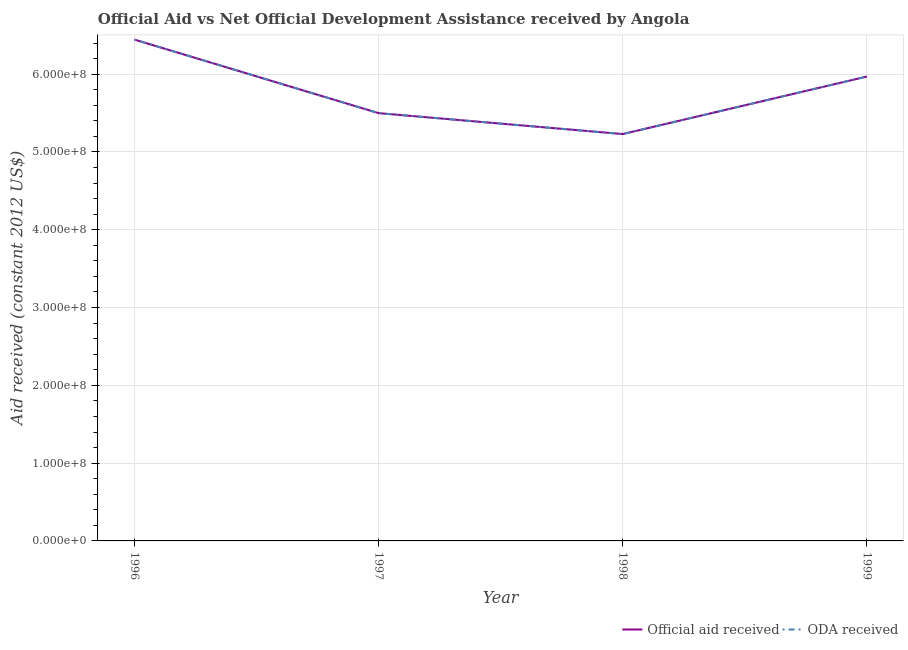What is the official aid received in 1996?
Provide a succinct answer. 6.44e+08. Across all years, what is the maximum oda received?
Keep it short and to the point. 6.44e+08. Across all years, what is the minimum oda received?
Offer a terse response. 5.23e+08. In which year was the oda received minimum?
Your response must be concise. 1998. What is the total official aid received in the graph?
Ensure brevity in your answer.  2.31e+09. What is the difference between the oda received in 1997 and that in 1998?
Give a very brief answer. 2.69e+07. What is the difference between the official aid received in 1997 and the oda received in 1996?
Keep it short and to the point. -9.46e+07. What is the average oda received per year?
Your answer should be compact. 5.79e+08. In how many years, is the official aid received greater than 340000000 US$?
Ensure brevity in your answer.  4. What is the ratio of the oda received in 1996 to that in 1999?
Your answer should be very brief. 1.08. What is the difference between the highest and the second highest oda received?
Provide a short and direct response. 4.75e+07. What is the difference between the highest and the lowest official aid received?
Offer a terse response. 1.21e+08. Does the oda received monotonically increase over the years?
Provide a succinct answer. No. Is the official aid received strictly greater than the oda received over the years?
Your answer should be very brief. No. Is the oda received strictly less than the official aid received over the years?
Offer a very short reply. No. How many lines are there?
Offer a terse response. 2. What is the difference between two consecutive major ticks on the Y-axis?
Keep it short and to the point. 1.00e+08. Does the graph contain any zero values?
Offer a terse response. No. Does the graph contain grids?
Offer a terse response. Yes. Where does the legend appear in the graph?
Provide a short and direct response. Bottom right. How many legend labels are there?
Offer a terse response. 2. What is the title of the graph?
Your response must be concise. Official Aid vs Net Official Development Assistance received by Angola . Does "National Tourists" appear as one of the legend labels in the graph?
Provide a short and direct response. No. What is the label or title of the Y-axis?
Ensure brevity in your answer.  Aid received (constant 2012 US$). What is the Aid received (constant 2012 US$) of Official aid received in 1996?
Ensure brevity in your answer.  6.44e+08. What is the Aid received (constant 2012 US$) in ODA received in 1996?
Keep it short and to the point. 6.44e+08. What is the Aid received (constant 2012 US$) in Official aid received in 1997?
Keep it short and to the point. 5.50e+08. What is the Aid received (constant 2012 US$) of ODA received in 1997?
Offer a very short reply. 5.50e+08. What is the Aid received (constant 2012 US$) in Official aid received in 1998?
Your answer should be very brief. 5.23e+08. What is the Aid received (constant 2012 US$) in ODA received in 1998?
Offer a terse response. 5.23e+08. What is the Aid received (constant 2012 US$) in Official aid received in 1999?
Provide a succinct answer. 5.97e+08. What is the Aid received (constant 2012 US$) of ODA received in 1999?
Offer a very short reply. 5.97e+08. Across all years, what is the maximum Aid received (constant 2012 US$) of Official aid received?
Offer a terse response. 6.44e+08. Across all years, what is the maximum Aid received (constant 2012 US$) of ODA received?
Ensure brevity in your answer.  6.44e+08. Across all years, what is the minimum Aid received (constant 2012 US$) in Official aid received?
Keep it short and to the point. 5.23e+08. Across all years, what is the minimum Aid received (constant 2012 US$) in ODA received?
Make the answer very short. 5.23e+08. What is the total Aid received (constant 2012 US$) of Official aid received in the graph?
Provide a succinct answer. 2.31e+09. What is the total Aid received (constant 2012 US$) in ODA received in the graph?
Offer a very short reply. 2.31e+09. What is the difference between the Aid received (constant 2012 US$) in Official aid received in 1996 and that in 1997?
Offer a terse response. 9.46e+07. What is the difference between the Aid received (constant 2012 US$) of ODA received in 1996 and that in 1997?
Ensure brevity in your answer.  9.46e+07. What is the difference between the Aid received (constant 2012 US$) of Official aid received in 1996 and that in 1998?
Offer a very short reply. 1.21e+08. What is the difference between the Aid received (constant 2012 US$) in ODA received in 1996 and that in 1998?
Your response must be concise. 1.21e+08. What is the difference between the Aid received (constant 2012 US$) in Official aid received in 1996 and that in 1999?
Your answer should be very brief. 4.75e+07. What is the difference between the Aid received (constant 2012 US$) in ODA received in 1996 and that in 1999?
Keep it short and to the point. 4.75e+07. What is the difference between the Aid received (constant 2012 US$) in Official aid received in 1997 and that in 1998?
Provide a succinct answer. 2.69e+07. What is the difference between the Aid received (constant 2012 US$) in ODA received in 1997 and that in 1998?
Ensure brevity in your answer.  2.69e+07. What is the difference between the Aid received (constant 2012 US$) in Official aid received in 1997 and that in 1999?
Your response must be concise. -4.71e+07. What is the difference between the Aid received (constant 2012 US$) in ODA received in 1997 and that in 1999?
Your answer should be very brief. -4.71e+07. What is the difference between the Aid received (constant 2012 US$) in Official aid received in 1998 and that in 1999?
Give a very brief answer. -7.39e+07. What is the difference between the Aid received (constant 2012 US$) in ODA received in 1998 and that in 1999?
Give a very brief answer. -7.39e+07. What is the difference between the Aid received (constant 2012 US$) in Official aid received in 1996 and the Aid received (constant 2012 US$) in ODA received in 1997?
Keep it short and to the point. 9.46e+07. What is the difference between the Aid received (constant 2012 US$) in Official aid received in 1996 and the Aid received (constant 2012 US$) in ODA received in 1998?
Provide a short and direct response. 1.21e+08. What is the difference between the Aid received (constant 2012 US$) in Official aid received in 1996 and the Aid received (constant 2012 US$) in ODA received in 1999?
Make the answer very short. 4.75e+07. What is the difference between the Aid received (constant 2012 US$) of Official aid received in 1997 and the Aid received (constant 2012 US$) of ODA received in 1998?
Make the answer very short. 2.69e+07. What is the difference between the Aid received (constant 2012 US$) in Official aid received in 1997 and the Aid received (constant 2012 US$) in ODA received in 1999?
Offer a very short reply. -4.71e+07. What is the difference between the Aid received (constant 2012 US$) of Official aid received in 1998 and the Aid received (constant 2012 US$) of ODA received in 1999?
Offer a terse response. -7.39e+07. What is the average Aid received (constant 2012 US$) of Official aid received per year?
Keep it short and to the point. 5.79e+08. What is the average Aid received (constant 2012 US$) in ODA received per year?
Ensure brevity in your answer.  5.79e+08. In the year 1997, what is the difference between the Aid received (constant 2012 US$) in Official aid received and Aid received (constant 2012 US$) in ODA received?
Provide a succinct answer. 0. In the year 1998, what is the difference between the Aid received (constant 2012 US$) in Official aid received and Aid received (constant 2012 US$) in ODA received?
Ensure brevity in your answer.  0. In the year 1999, what is the difference between the Aid received (constant 2012 US$) in Official aid received and Aid received (constant 2012 US$) in ODA received?
Offer a very short reply. 0. What is the ratio of the Aid received (constant 2012 US$) in Official aid received in 1996 to that in 1997?
Your answer should be compact. 1.17. What is the ratio of the Aid received (constant 2012 US$) in ODA received in 1996 to that in 1997?
Offer a terse response. 1.17. What is the ratio of the Aid received (constant 2012 US$) of Official aid received in 1996 to that in 1998?
Give a very brief answer. 1.23. What is the ratio of the Aid received (constant 2012 US$) of ODA received in 1996 to that in 1998?
Provide a succinct answer. 1.23. What is the ratio of the Aid received (constant 2012 US$) in Official aid received in 1996 to that in 1999?
Give a very brief answer. 1.08. What is the ratio of the Aid received (constant 2012 US$) in ODA received in 1996 to that in 1999?
Provide a short and direct response. 1.08. What is the ratio of the Aid received (constant 2012 US$) of Official aid received in 1997 to that in 1998?
Make the answer very short. 1.05. What is the ratio of the Aid received (constant 2012 US$) of ODA received in 1997 to that in 1998?
Provide a short and direct response. 1.05. What is the ratio of the Aid received (constant 2012 US$) in Official aid received in 1997 to that in 1999?
Make the answer very short. 0.92. What is the ratio of the Aid received (constant 2012 US$) of ODA received in 1997 to that in 1999?
Offer a terse response. 0.92. What is the ratio of the Aid received (constant 2012 US$) of Official aid received in 1998 to that in 1999?
Keep it short and to the point. 0.88. What is the ratio of the Aid received (constant 2012 US$) in ODA received in 1998 to that in 1999?
Your response must be concise. 0.88. What is the difference between the highest and the second highest Aid received (constant 2012 US$) in Official aid received?
Keep it short and to the point. 4.75e+07. What is the difference between the highest and the second highest Aid received (constant 2012 US$) of ODA received?
Your answer should be very brief. 4.75e+07. What is the difference between the highest and the lowest Aid received (constant 2012 US$) in Official aid received?
Keep it short and to the point. 1.21e+08. What is the difference between the highest and the lowest Aid received (constant 2012 US$) in ODA received?
Offer a terse response. 1.21e+08. 